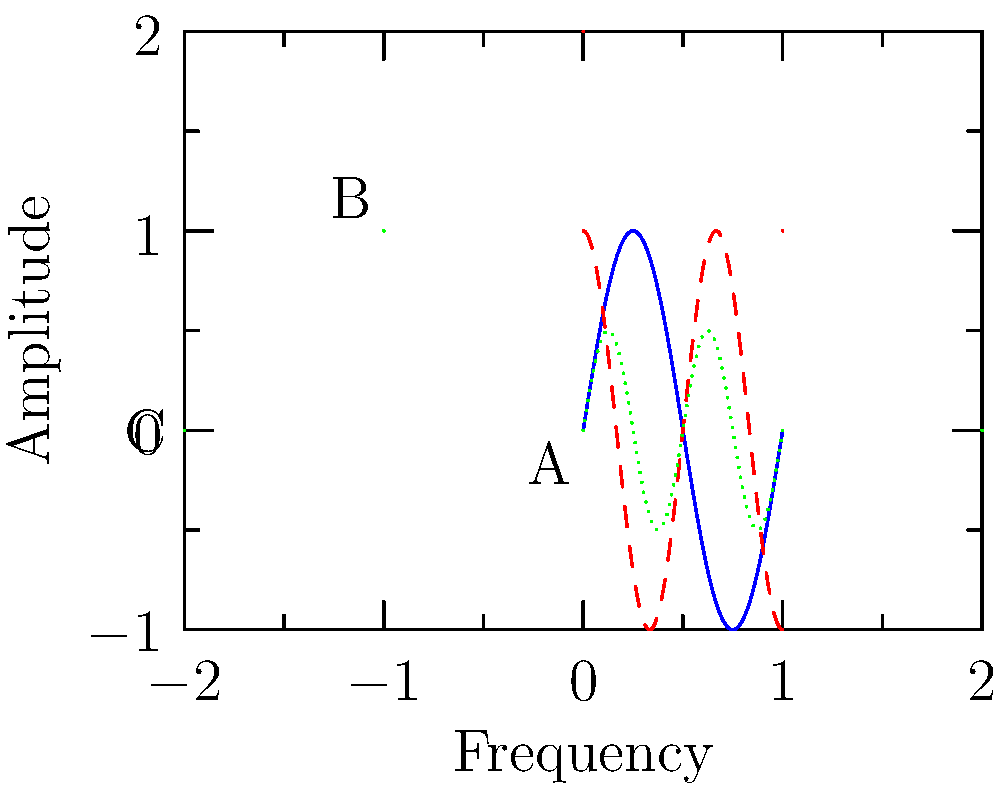Match the constellation patterns (A, B, C) with their corresponding celestial sound frequency patterns (1, 2, 3) based on their complexity and shape characteristics. What is the correct pairing? To match the constellation patterns with their corresponding celestial sound frequency patterns, we need to analyze the complexity and shape characteristics of both:

1. Constellation A: Diamond shape, 4 stars, moderate complexity
   Frequency 1: Sinusoidal wave, moderate frequency, consistent amplitude

2. Constellation B: Y-shape, 4 stars, moderate complexity with vertical extension
   Frequency 2: Cosine wave, higher frequency than 1, consistent amplitude

3. Constellation C: W-shape, 5 stars, highest complexity
   Frequency 3: Sinusoidal wave, highest frequency, reduced amplitude

Matching process:
1. Constellation A matches with Frequency 1 due to their moderate complexity and consistent pattern.
2. Constellation B corresponds to Frequency 2 because of its higher complexity and vertical extension, similar to the cosine wave's faster oscillation.
3. Constellation C pairs with Frequency 3 as both have the highest complexity, with the reduced amplitude of the wave mirroring the spread-out nature of the constellation.

Therefore, the correct pairing is:
A-1, B-2, C-3
Answer: A-1, B-2, C-3 